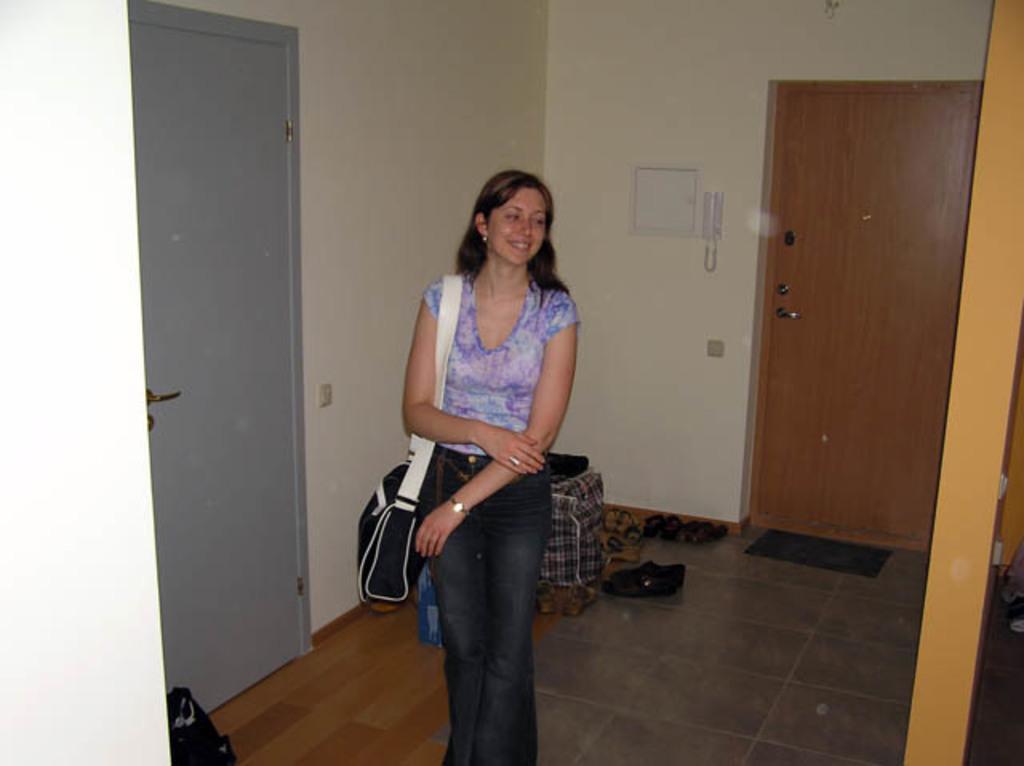In one or two sentences, can you explain what this image depicts? In the center of the image there is a lady wearing a bag. In the background of the image there is a wall. There is a door. There are many foot wears. 